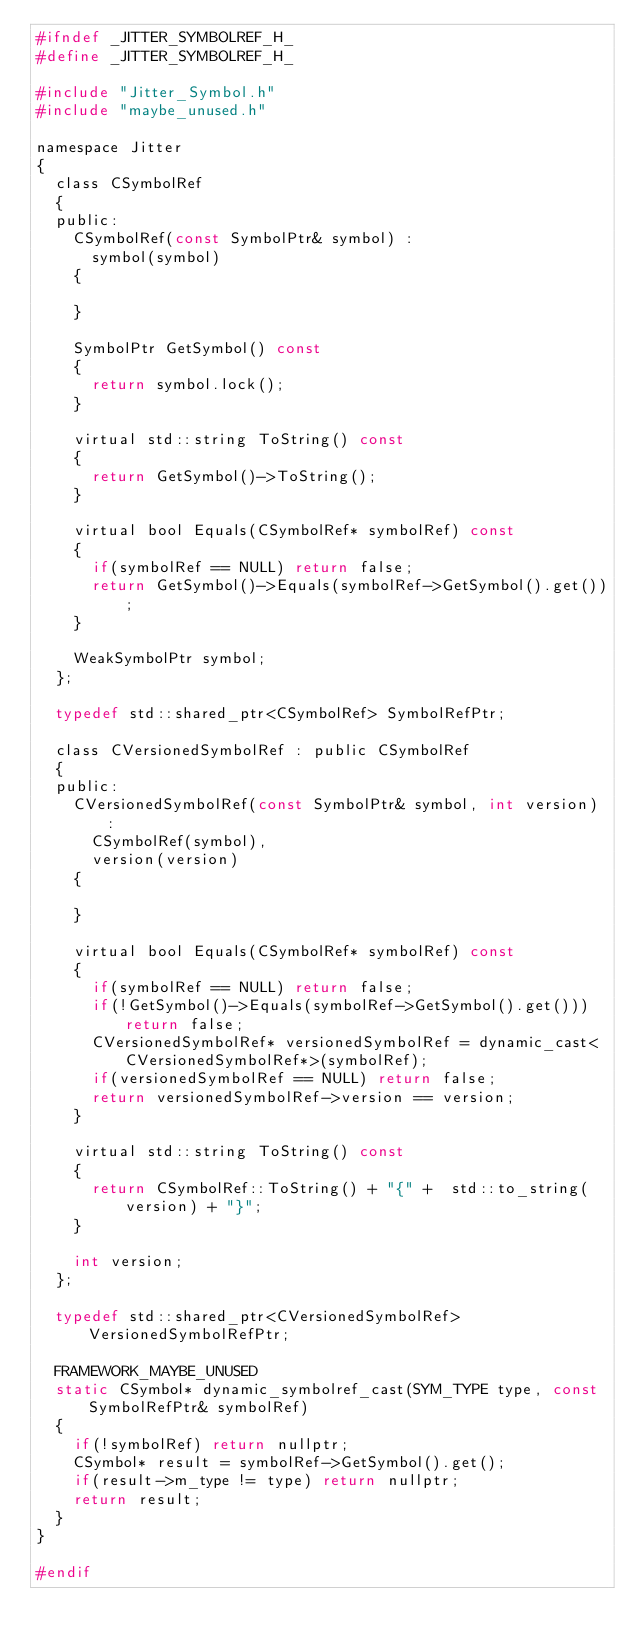<code> <loc_0><loc_0><loc_500><loc_500><_C_>#ifndef _JITTER_SYMBOLREF_H_
#define _JITTER_SYMBOLREF_H_

#include "Jitter_Symbol.h"
#include "maybe_unused.h"

namespace Jitter
{
	class CSymbolRef
	{
	public:
		CSymbolRef(const SymbolPtr& symbol) :
		  symbol(symbol)
		{
			
		}

		SymbolPtr GetSymbol() const
		{
			return symbol.lock();
		}

		virtual std::string ToString() const
		{
			return GetSymbol()->ToString();
		}

		virtual bool Equals(CSymbolRef* symbolRef) const
		{
			if(symbolRef == NULL) return false;
			return GetSymbol()->Equals(symbolRef->GetSymbol().get());
		}

		WeakSymbolPtr symbol;
	};

	typedef std::shared_ptr<CSymbolRef> SymbolRefPtr;

	class CVersionedSymbolRef : public CSymbolRef
	{
	public:
		CVersionedSymbolRef(const SymbolPtr& symbol, int version) :
		  CSymbolRef(symbol),
		  version(version)
		{

		}

		virtual bool Equals(CSymbolRef* symbolRef) const
		{
			if(symbolRef == NULL) return false;
			if(!GetSymbol()->Equals(symbolRef->GetSymbol().get())) return false;
			CVersionedSymbolRef* versionedSymbolRef = dynamic_cast<CVersionedSymbolRef*>(symbolRef);
			if(versionedSymbolRef == NULL) return false;
			return versionedSymbolRef->version == version;
		}

		virtual std::string ToString() const
		{
			return CSymbolRef::ToString() + "{" +  std::to_string(version) + "}";
		}

		int version;
	};

	typedef std::shared_ptr<CVersionedSymbolRef> VersionedSymbolRefPtr;

	FRAMEWORK_MAYBE_UNUSED
	static CSymbol* dynamic_symbolref_cast(SYM_TYPE type, const SymbolRefPtr& symbolRef)
	{
		if(!symbolRef) return nullptr;
		CSymbol* result = symbolRef->GetSymbol().get();
		if(result->m_type != type) return nullptr;
		return result;
	}
}

#endif
</code> 